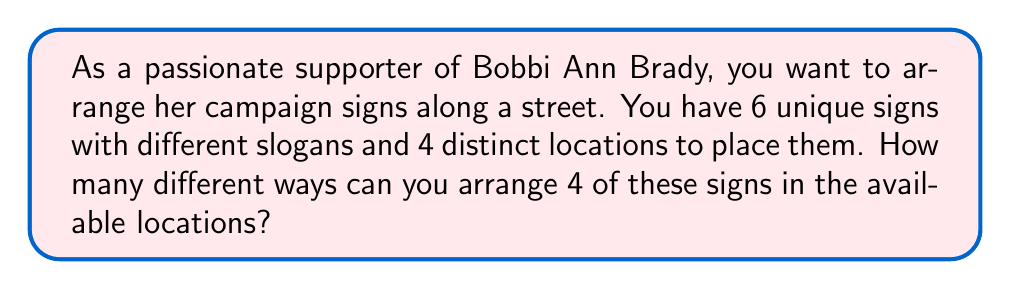Help me with this question. Let's approach this step-by-step:

1) This is a permutation problem. We are selecting 4 signs out of 6 and arranging them in a specific order.

2) The formula for permutations is:

   $$P(n,r) = \frac{n!}{(n-r)!}$$

   Where $n$ is the total number of items to choose from, and $r$ is the number of items being chosen.

3) In this case, $n = 6$ (total number of signs) and $r = 4$ (number of locations/signs to be placed).

4) Plugging these values into the formula:

   $$P(6,4) = \frac{6!}{(6-4)!} = \frac{6!}{2!}$$

5) Expand this:
   $$\frac{6 \times 5 \times 4 \times 3 \times 2!}{2!}$$

6) The 2! cancels out in the numerator and denominator:

   $$6 \times 5 \times 4 \times 3 = 360$$

Therefore, there are 360 different ways to arrange 4 of Bobbi Ann Brady's campaign signs in the 4 available locations.
Answer: 360 